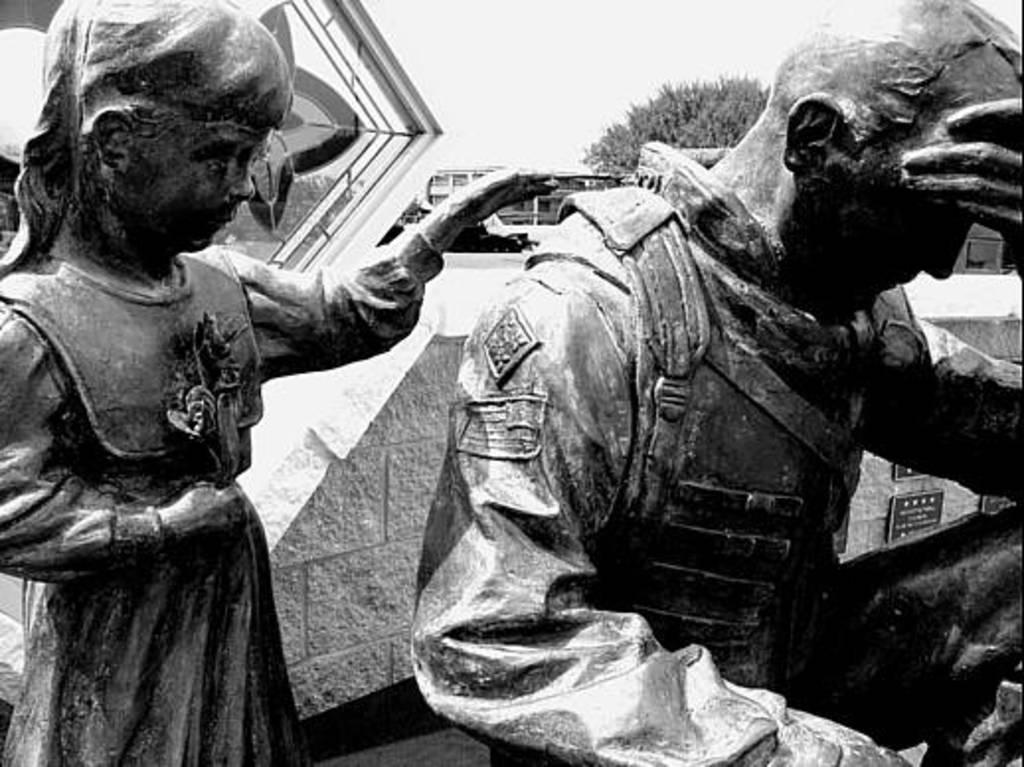Please provide a concise description of this image. This is a black and white picture. In this picture, we see the statues of a girl and a man. Behind that, we see a wall and we see the commemorative plaques are placed on the wall. There are trees and the buildings in the background. At the top, we see the sky. 